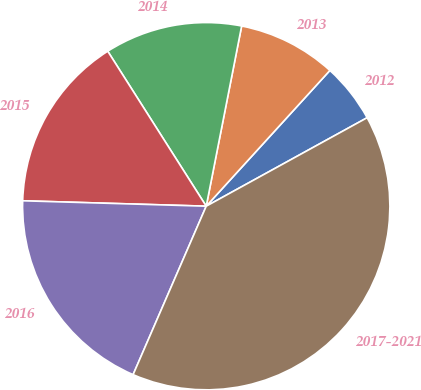Convert chart to OTSL. <chart><loc_0><loc_0><loc_500><loc_500><pie_chart><fcel>2012<fcel>2013<fcel>2014<fcel>2015<fcel>2016<fcel>2017-2021<nl><fcel>5.24%<fcel>8.67%<fcel>12.1%<fcel>15.52%<fcel>18.95%<fcel>39.52%<nl></chart> 